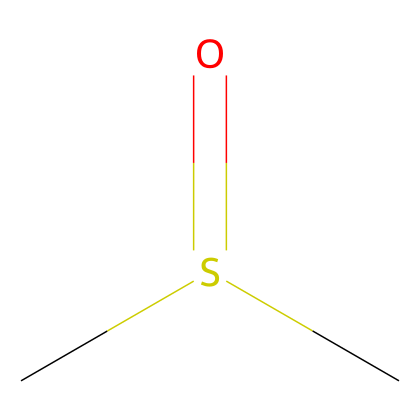What is the name of this chemical? The SMILES representation "CS(=O)C" corresponds to dimethyl sulfoxide, which is a common name for the structure shown.
Answer: dimethyl sulfoxide How many carbon atoms are in this molecule? The structure has two carbon atoms, indicated by the "C" in the SMILES.
Answer: 2 What functional group is present in this compound? The presence of the "S(=O)" in the structure indicates that there is a sulfoxide functional group in the molecule.
Answer: sulfoxide What is the oxidation state of sulfur in this compound? Sulfur typically has an oxidation state of +4 in sulfoxides, as it is bonded to one oxygen with a double bond and two carbon atoms.
Answer: +4 What type of compound is dimethyl sulfoxide? This compound is categorized as an organosulfur compound due to the presence of sulfur within an organic framework.
Answer: organosulfur Does this compound have polar properties? The presence of the sulfoxide group (S=O) creates a polar bond, making dimethyl sulfoxide a polar solvent.
Answer: yes How many oxygen atoms are in this molecule? The structure indicates one oxygen atom is present, shown by the "O" in the SMILES representation.
Answer: 1 